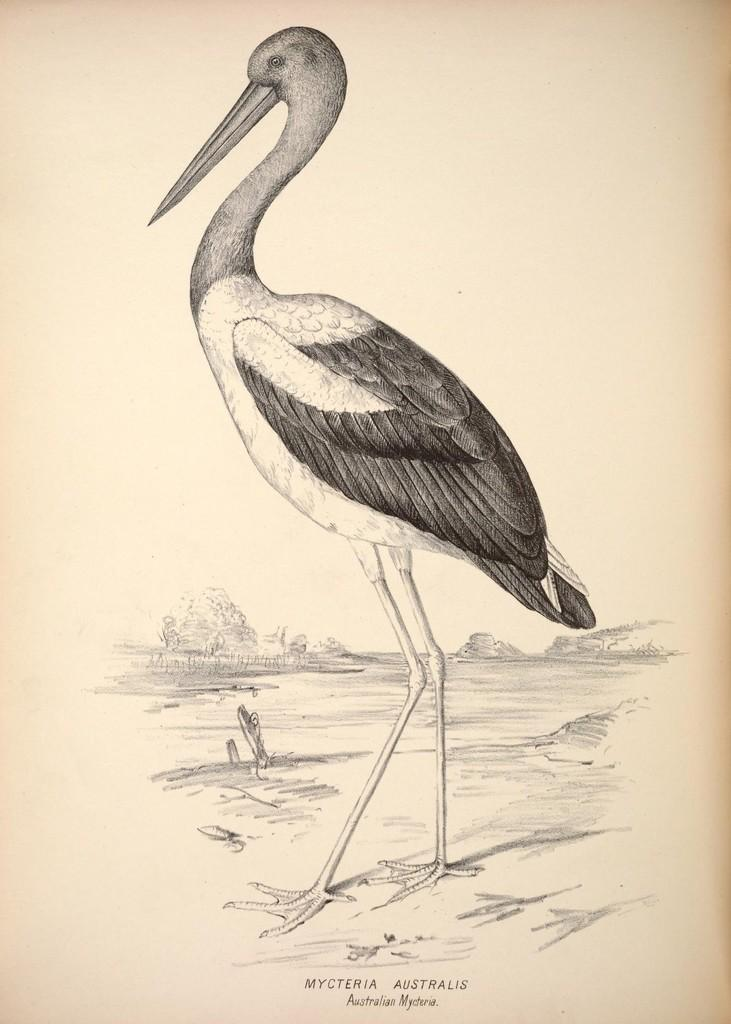What is the main subject of the image? The main subject of the image is a sketch of a bird. Is there any text associated with the image? Yes, there is text at the bottom of the image. What type of kettle is depicted in the image? There is no kettle present in the image; it is a sketch of a bird with text at the bottom. 